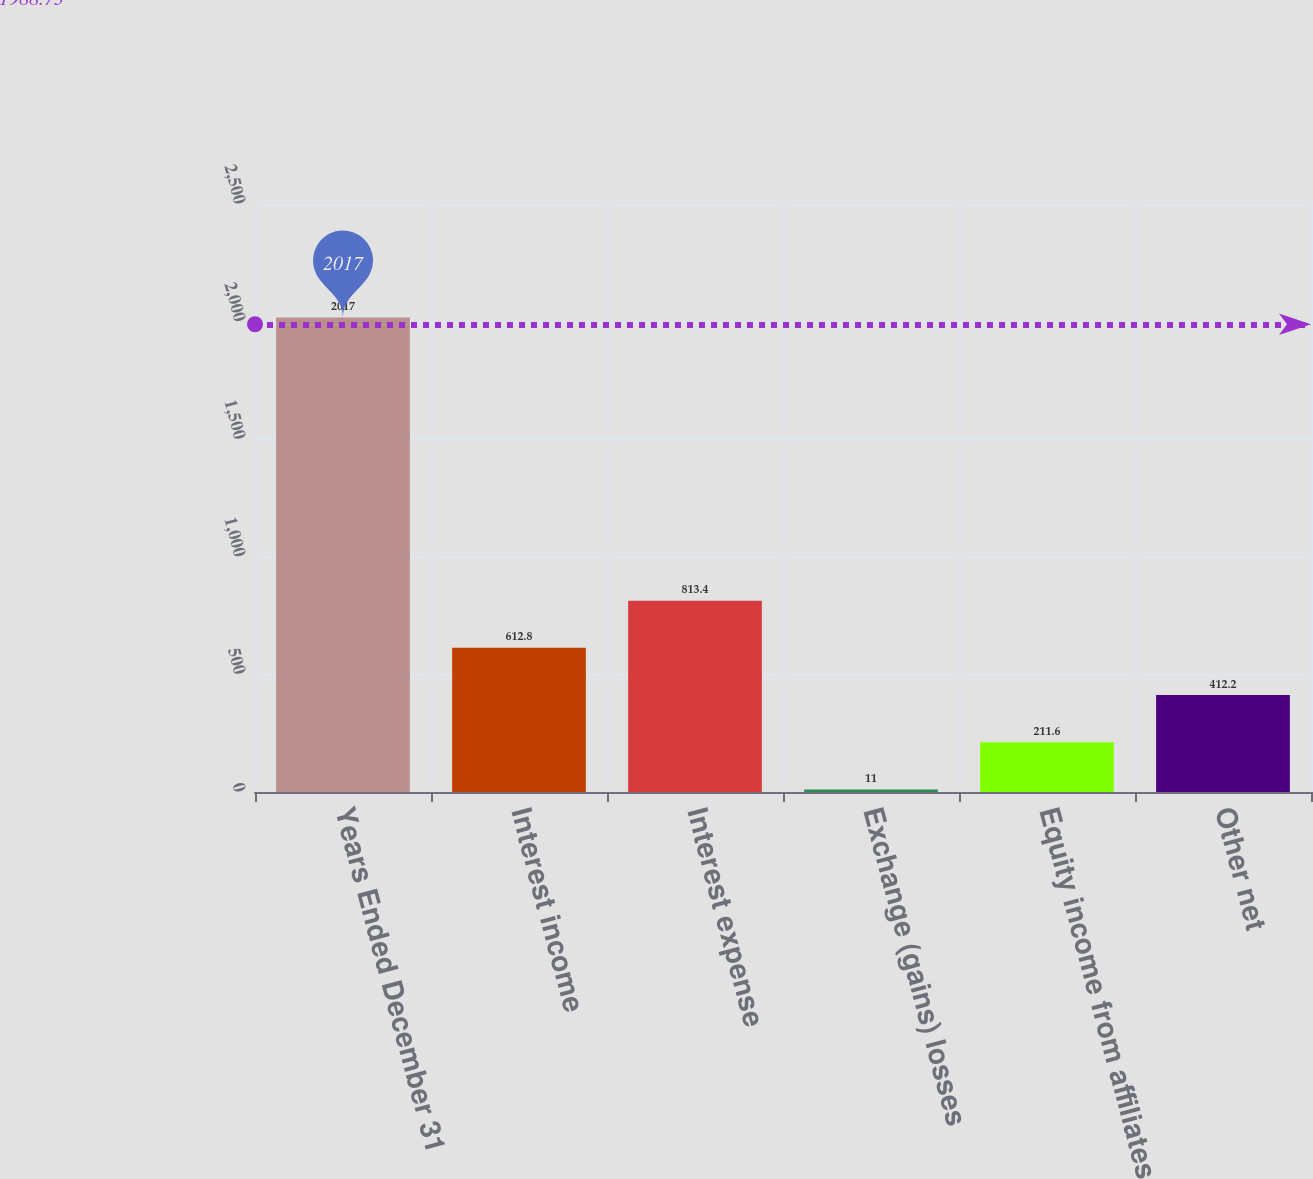<chart> <loc_0><loc_0><loc_500><loc_500><bar_chart><fcel>Years Ended December 31<fcel>Interest income<fcel>Interest expense<fcel>Exchange (gains) losses<fcel>Equity income from affiliates<fcel>Other net<nl><fcel>2017<fcel>612.8<fcel>813.4<fcel>11<fcel>211.6<fcel>412.2<nl></chart> 